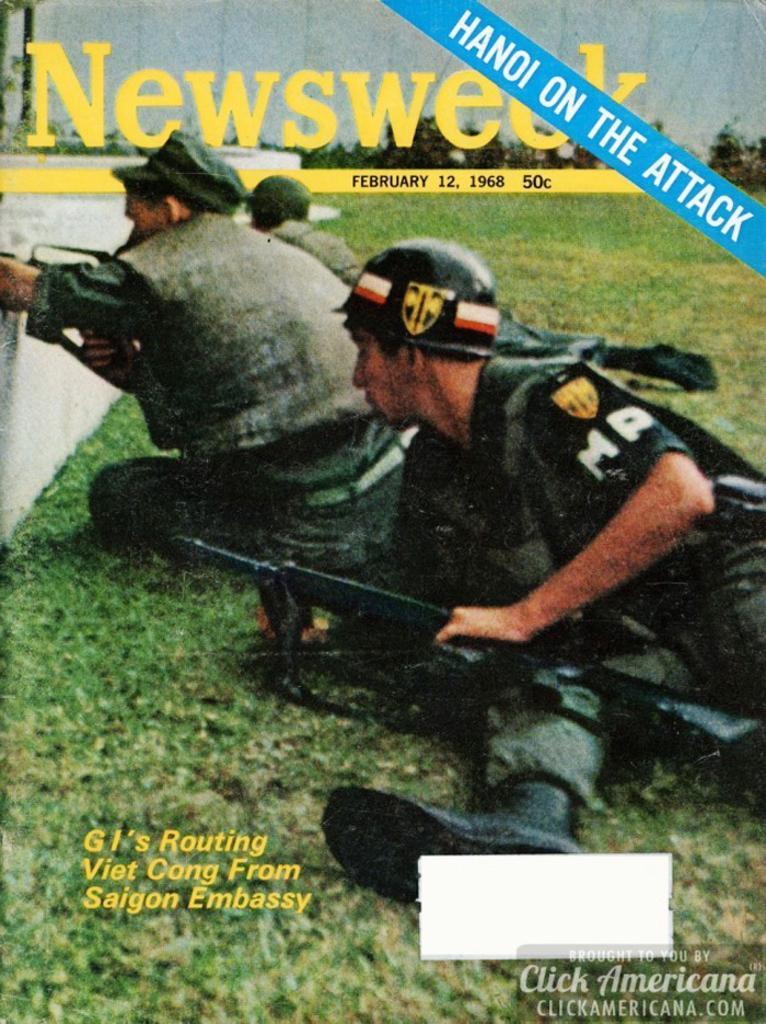Could you give a brief overview of what you see in this image? In this image there is a wall in the left corner. There is green grass at the bottom. There are people holding objects and some text in the foreground. There are trees, text and wall in the background. 